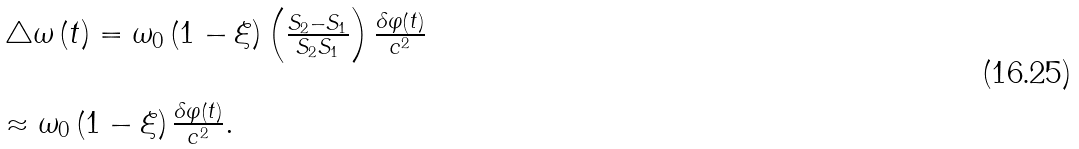Convert formula to latex. <formula><loc_0><loc_0><loc_500><loc_500>\begin{array} { l l } \triangle \omega \left ( t \right ) = \omega _ { 0 } \left ( 1 - \xi \right ) \left ( \frac { S _ { 2 } - S _ { 1 } } { S _ { 2 } S _ { 1 } } \right ) \frac { \delta \varphi \left ( t \right ) } { c ^ { 2 } } \\ \\ \approx \omega _ { 0 } \left ( 1 - \xi \right ) \frac { \delta \varphi \left ( t \right ) } { c ^ { 2 } } . \end{array}</formula> 